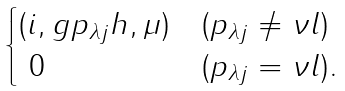Convert formula to latex. <formula><loc_0><loc_0><loc_500><loc_500>\begin{cases} ( i , g p _ { \lambda j } h , \mu ) & ( p _ { \lambda j } \not = \nu l ) \\ \ 0 & ( p _ { \lambda j } = \nu l ) . \\ \end{cases}</formula> 